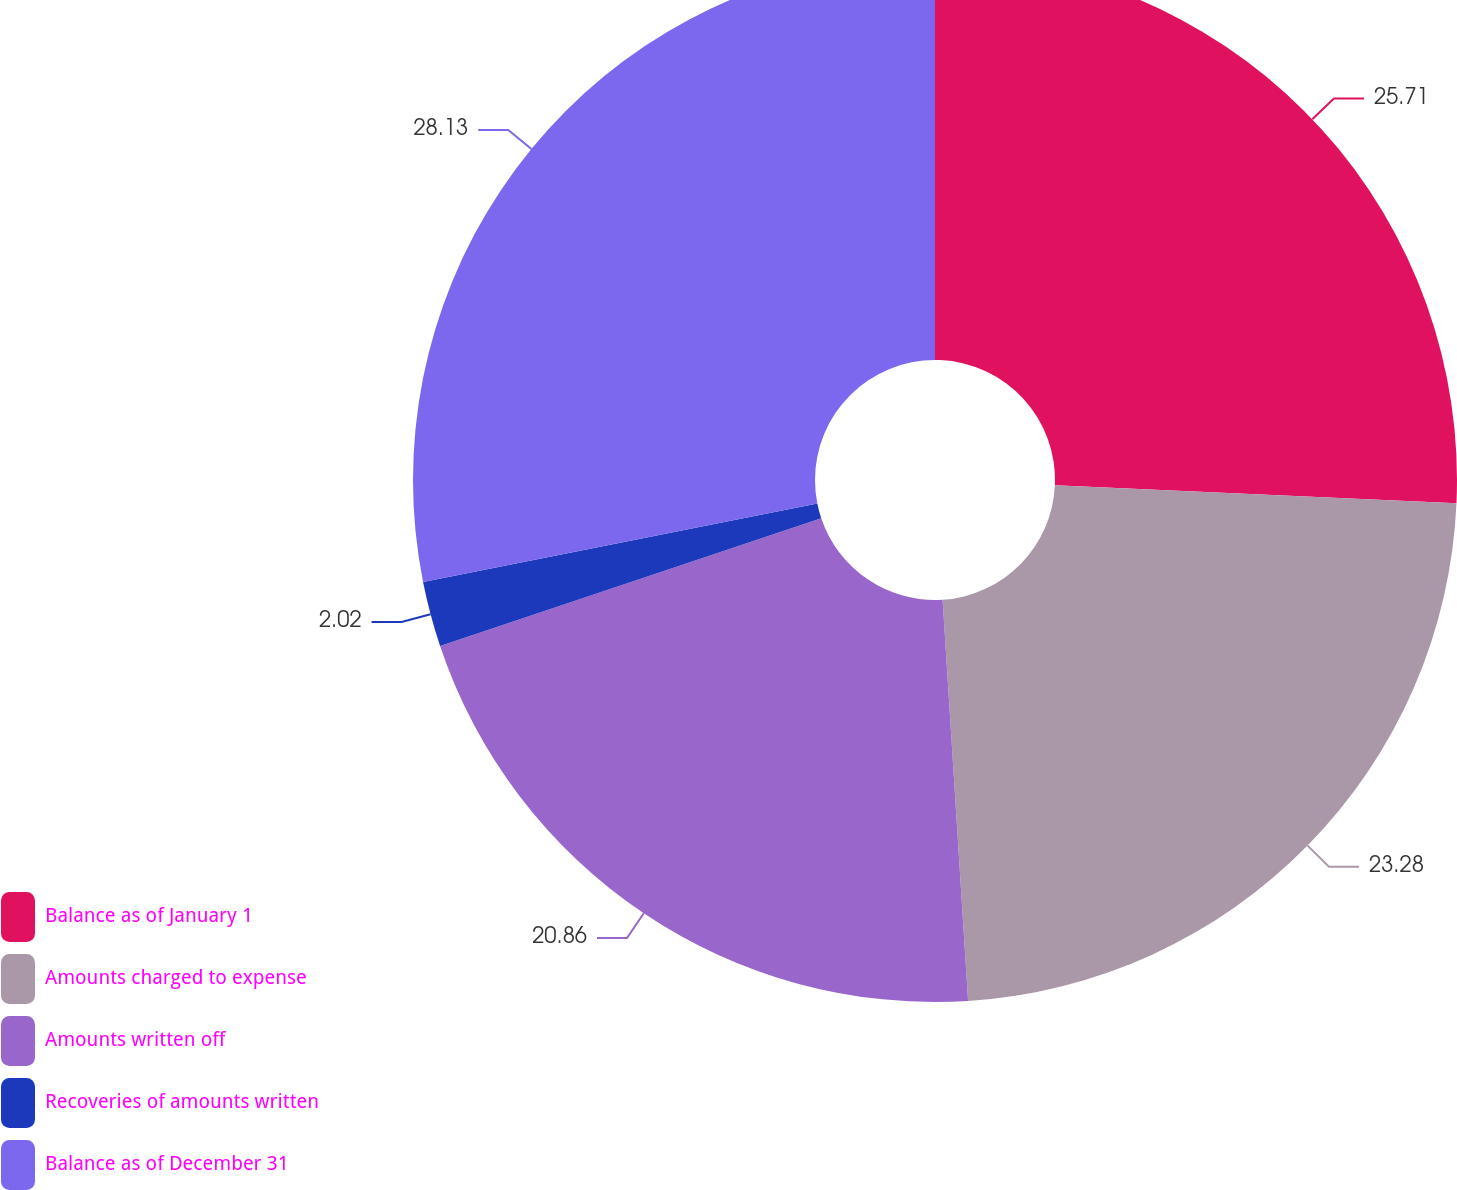Convert chart to OTSL. <chart><loc_0><loc_0><loc_500><loc_500><pie_chart><fcel>Balance as of January 1<fcel>Amounts charged to expense<fcel>Amounts written off<fcel>Recoveries of amounts written<fcel>Balance as of December 31<nl><fcel>25.71%<fcel>23.28%<fcel>20.86%<fcel>2.02%<fcel>28.13%<nl></chart> 